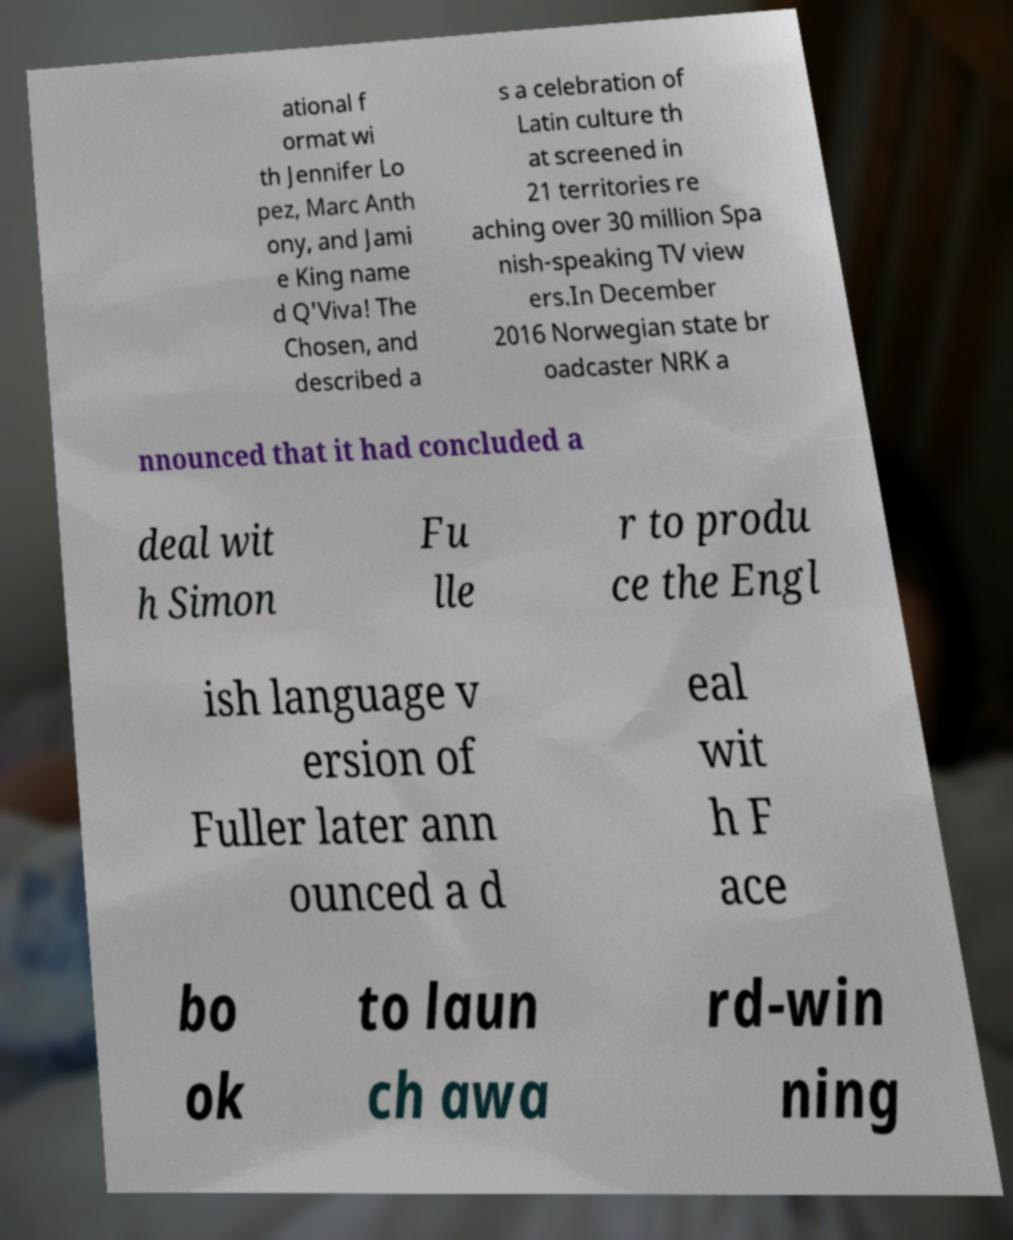I need the written content from this picture converted into text. Can you do that? ational f ormat wi th Jennifer Lo pez, Marc Anth ony, and Jami e King name d Q'Viva! The Chosen, and described a s a celebration of Latin culture th at screened in 21 territories re aching over 30 million Spa nish-speaking TV view ers.In December 2016 Norwegian state br oadcaster NRK a nnounced that it had concluded a deal wit h Simon Fu lle r to produ ce the Engl ish language v ersion of Fuller later ann ounced a d eal wit h F ace bo ok to laun ch awa rd-win ning 